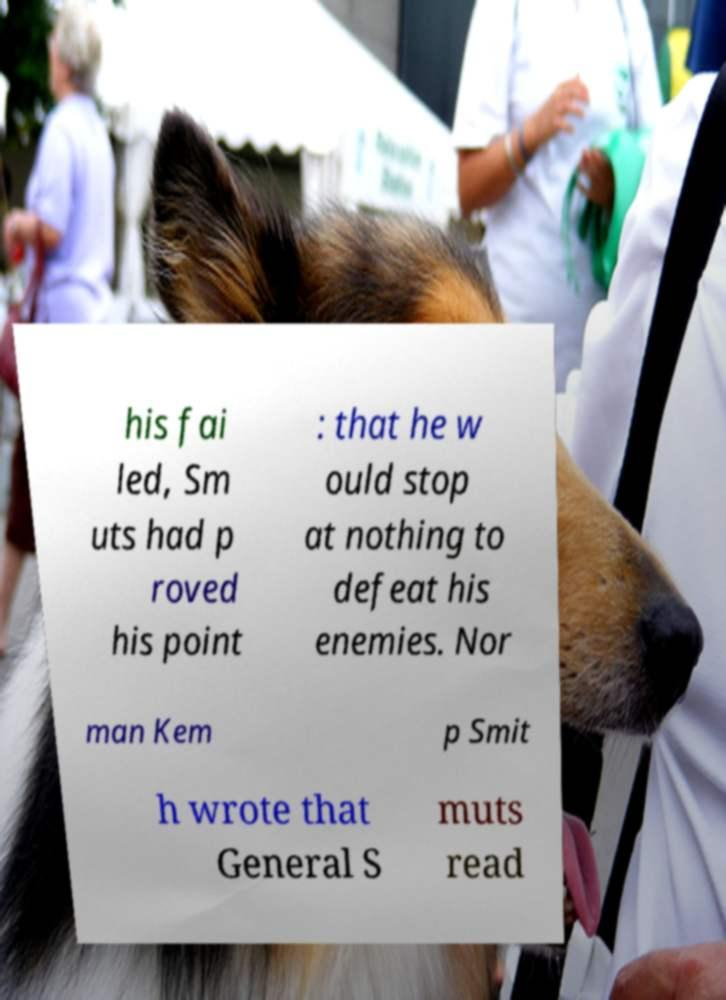What messages or text are displayed in this image? I need them in a readable, typed format. his fai led, Sm uts had p roved his point : that he w ould stop at nothing to defeat his enemies. Nor man Kem p Smit h wrote that General S muts read 